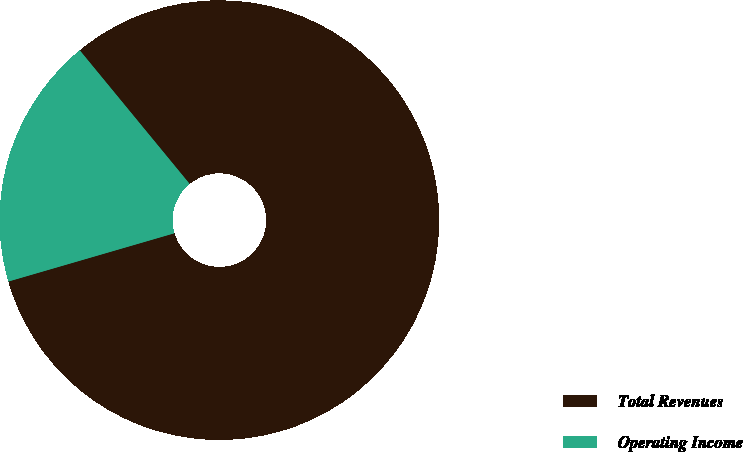Convert chart to OTSL. <chart><loc_0><loc_0><loc_500><loc_500><pie_chart><fcel>Total Revenues<fcel>Operating Income<nl><fcel>81.45%<fcel>18.55%<nl></chart> 